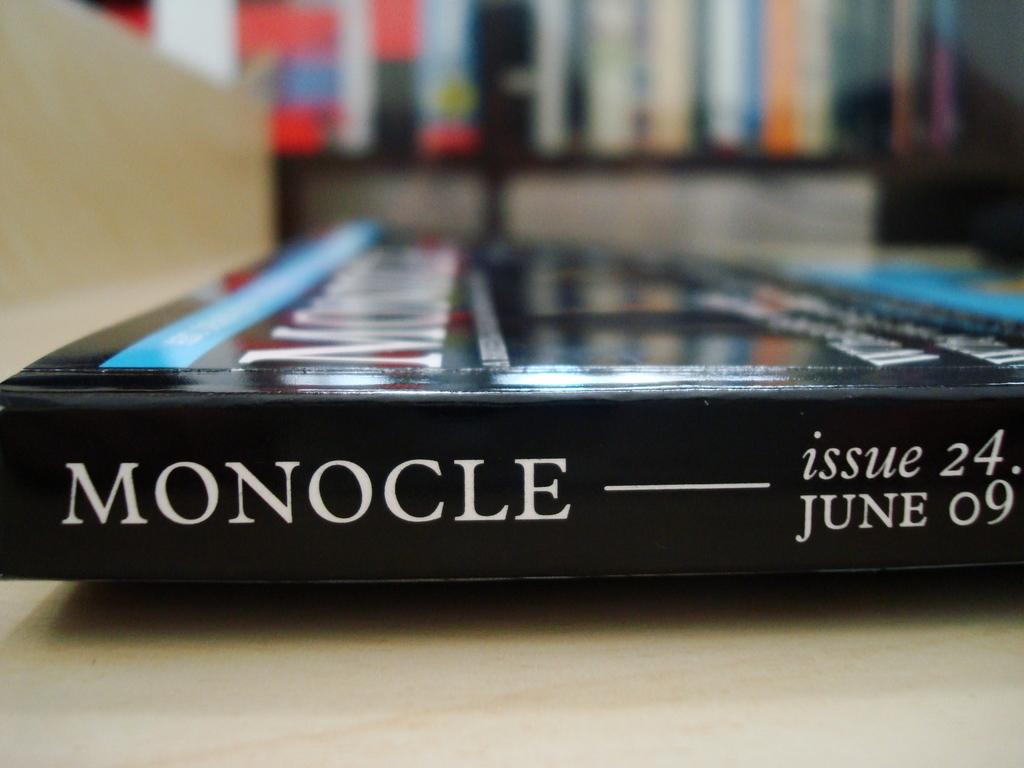<image>
Offer a succinct explanation of the picture presented. An issue of Monocle that was published in June 2009. 